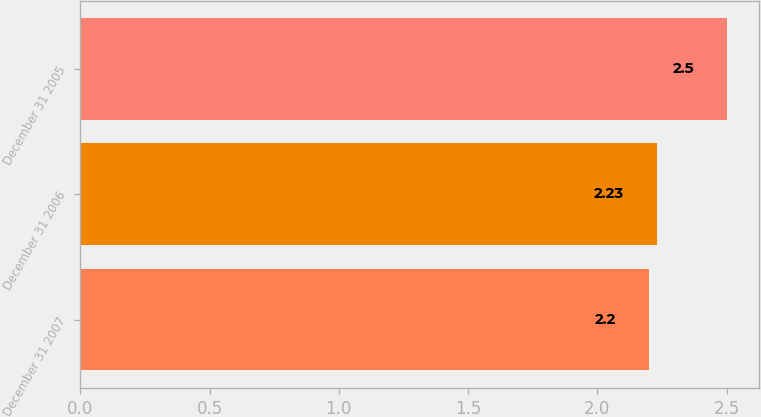<chart> <loc_0><loc_0><loc_500><loc_500><bar_chart><fcel>December 31 2007<fcel>December 31 2006<fcel>December 31 2005<nl><fcel>2.2<fcel>2.23<fcel>2.5<nl></chart> 